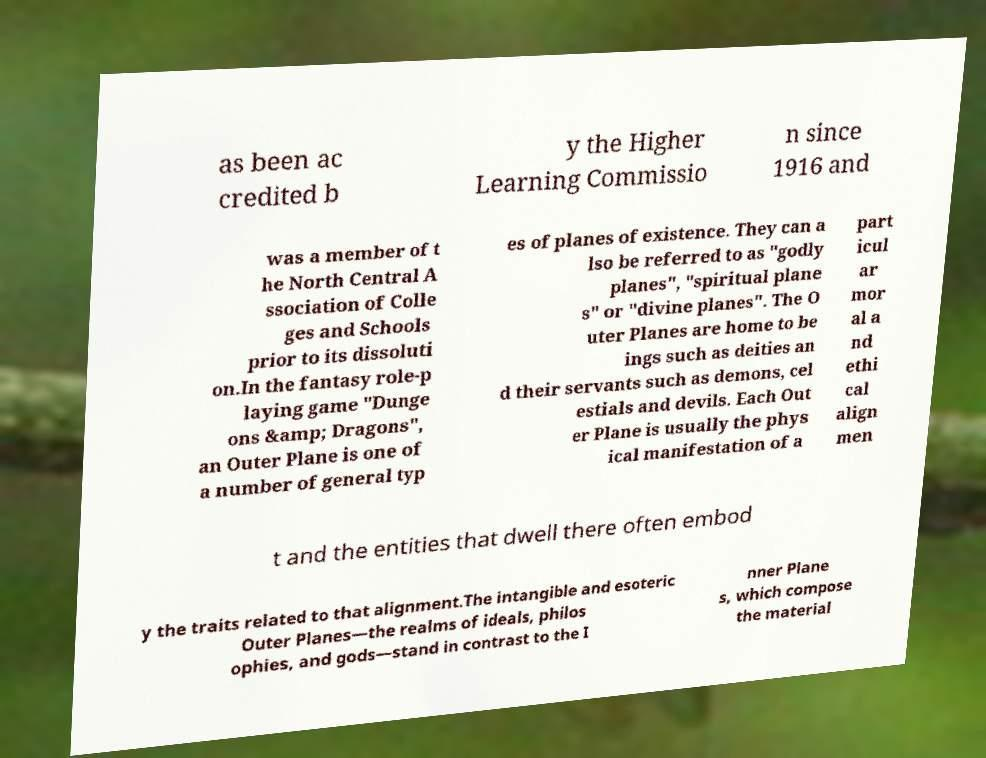For documentation purposes, I need the text within this image transcribed. Could you provide that? as been ac credited b y the Higher Learning Commissio n since 1916 and was a member of t he North Central A ssociation of Colle ges and Schools prior to its dissoluti on.In the fantasy role-p laying game "Dunge ons &amp; Dragons", an Outer Plane is one of a number of general typ es of planes of existence. They can a lso be referred to as "godly planes", "spiritual plane s" or "divine planes". The O uter Planes are home to be ings such as deities an d their servants such as demons, cel estials and devils. Each Out er Plane is usually the phys ical manifestation of a part icul ar mor al a nd ethi cal align men t and the entities that dwell there often embod y the traits related to that alignment.The intangible and esoteric Outer Planes—the realms of ideals, philos ophies, and gods—stand in contrast to the I nner Plane s, which compose the material 